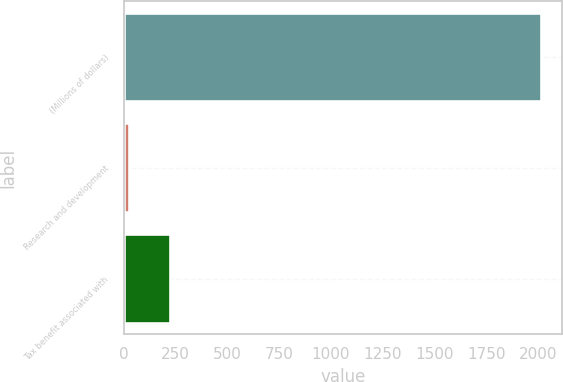<chart> <loc_0><loc_0><loc_500><loc_500><bar_chart><fcel>(Millions of dollars)<fcel>Research and development<fcel>Tax benefit associated with<nl><fcel>2016<fcel>22<fcel>221.4<nl></chart> 